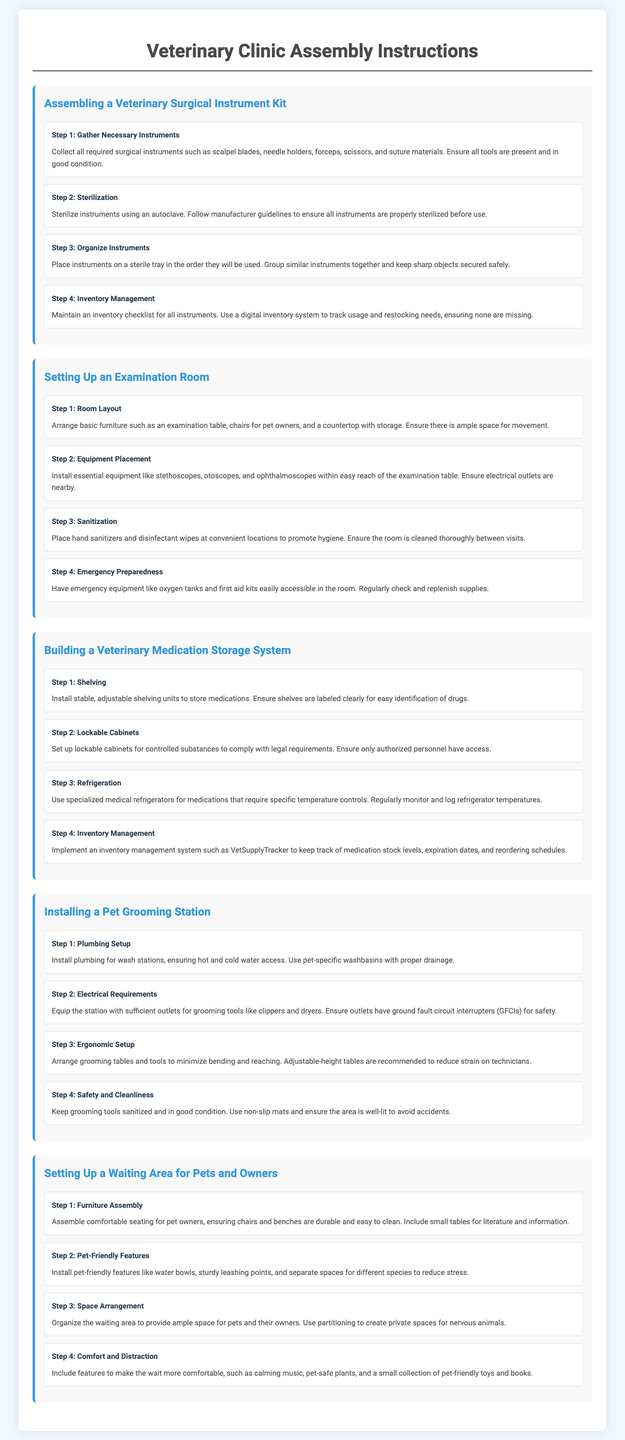What is the first step in assembling a surgical instrument kit? The first step is to gather all necessary instruments including scalpel blades, needle holders, forceps, scissors, and suture materials.
Answer: Gather necessary instruments How many steps are there in setting up an examination room? The section on setting up an examination room includes four steps for efficient setup.
Answer: Four steps What should be used to sterilize instruments? Instruments should be sterilized using an autoclave as per manufacturer guidelines.
Answer: Autoclave What feature is recommended for ergonomic setup in a grooming station? Adjustable-height tables are recommended to reduce strain on technicians during grooming.
Answer: Adjustable-height tables How should medications be stored to comply with legal requirements? Controlled substances should be stored in lockable cabinets that ensure only authorized personnel have access.
Answer: Lockable cabinets What should be placed at convenient locations to promote hygiene in the examination room? Hand sanitizers and disinfectant wipes should be placed at convenient locations in the examination room.
Answer: Hand sanitizers and disinfectant wipes How can you track medication stock levels? Implement an inventory management system like VetSupplyTracker to keep track of medication stock levels.
Answer: VetSupplyTracker What type of seating should be assembled for the waiting area? Comfortable seating for pet owners should be assembled, ensuring durability and easy cleaning.
Answer: Comfortable seating What is one feature included to help reduce stress for pets in the waiting area? Pet-friendly features like water bowls are installed to help reduce stress for pets.
Answer: Water bowls 